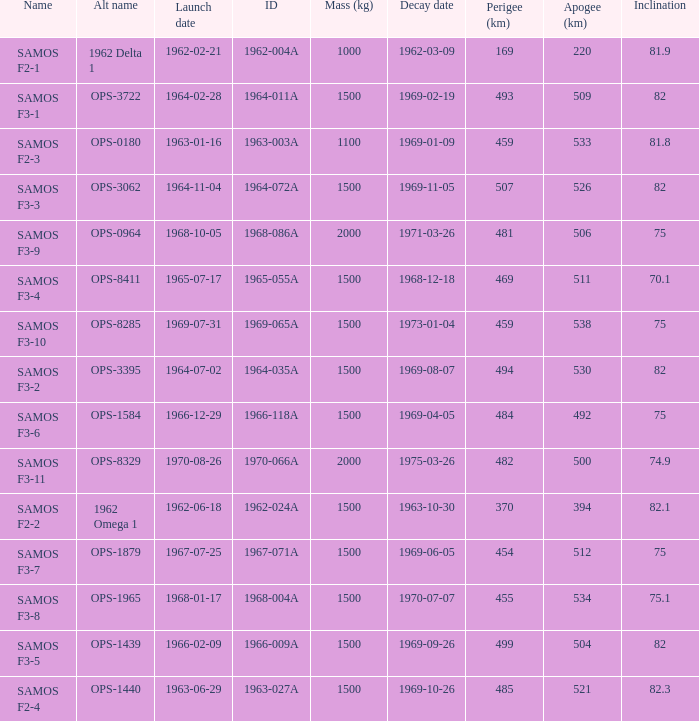What was the maximum perigee on 1969-01-09? 459.0. Could you parse the entire table as a dict? {'header': ['Name', 'Alt name', 'Launch date', 'ID', 'Mass (kg)', 'Decay date', 'Perigee (km)', 'Apogee (km)', 'Inclination'], 'rows': [['SAMOS F2-1', '1962 Delta 1', '1962-02-21', '1962-004A', '1000', '1962-03-09', '169', '220', '81.9'], ['SAMOS F3-1', 'OPS-3722', '1964-02-28', '1964-011A', '1500', '1969-02-19', '493', '509', '82'], ['SAMOS F2-3', 'OPS-0180', '1963-01-16', '1963-003A', '1100', '1969-01-09', '459', '533', '81.8'], ['SAMOS F3-3', 'OPS-3062', '1964-11-04', '1964-072A', '1500', '1969-11-05', '507', '526', '82'], ['SAMOS F3-9', 'OPS-0964', '1968-10-05', '1968-086A', '2000', '1971-03-26', '481', '506', '75'], ['SAMOS F3-4', 'OPS-8411', '1965-07-17', '1965-055A', '1500', '1968-12-18', '469', '511', '70.1'], ['SAMOS F3-10', 'OPS-8285', '1969-07-31', '1969-065A', '1500', '1973-01-04', '459', '538', '75'], ['SAMOS F3-2', 'OPS-3395', '1964-07-02', '1964-035A', '1500', '1969-08-07', '494', '530', '82'], ['SAMOS F3-6', 'OPS-1584', '1966-12-29', '1966-118A', '1500', '1969-04-05', '484', '492', '75'], ['SAMOS F3-11', 'OPS-8329', '1970-08-26', '1970-066A', '2000', '1975-03-26', '482', '500', '74.9'], ['SAMOS F2-2', '1962 Omega 1', '1962-06-18', '1962-024A', '1500', '1963-10-30', '370', '394', '82.1'], ['SAMOS F3-7', 'OPS-1879', '1967-07-25', '1967-071A', '1500', '1969-06-05', '454', '512', '75'], ['SAMOS F3-8', 'OPS-1965', '1968-01-17', '1968-004A', '1500', '1970-07-07', '455', '534', '75.1'], ['SAMOS F3-5', 'OPS-1439', '1966-02-09', '1966-009A', '1500', '1969-09-26', '499', '504', '82'], ['SAMOS F2-4', 'OPS-1440', '1963-06-29', '1963-027A', '1500', '1969-10-26', '485', '521', '82.3']]} 